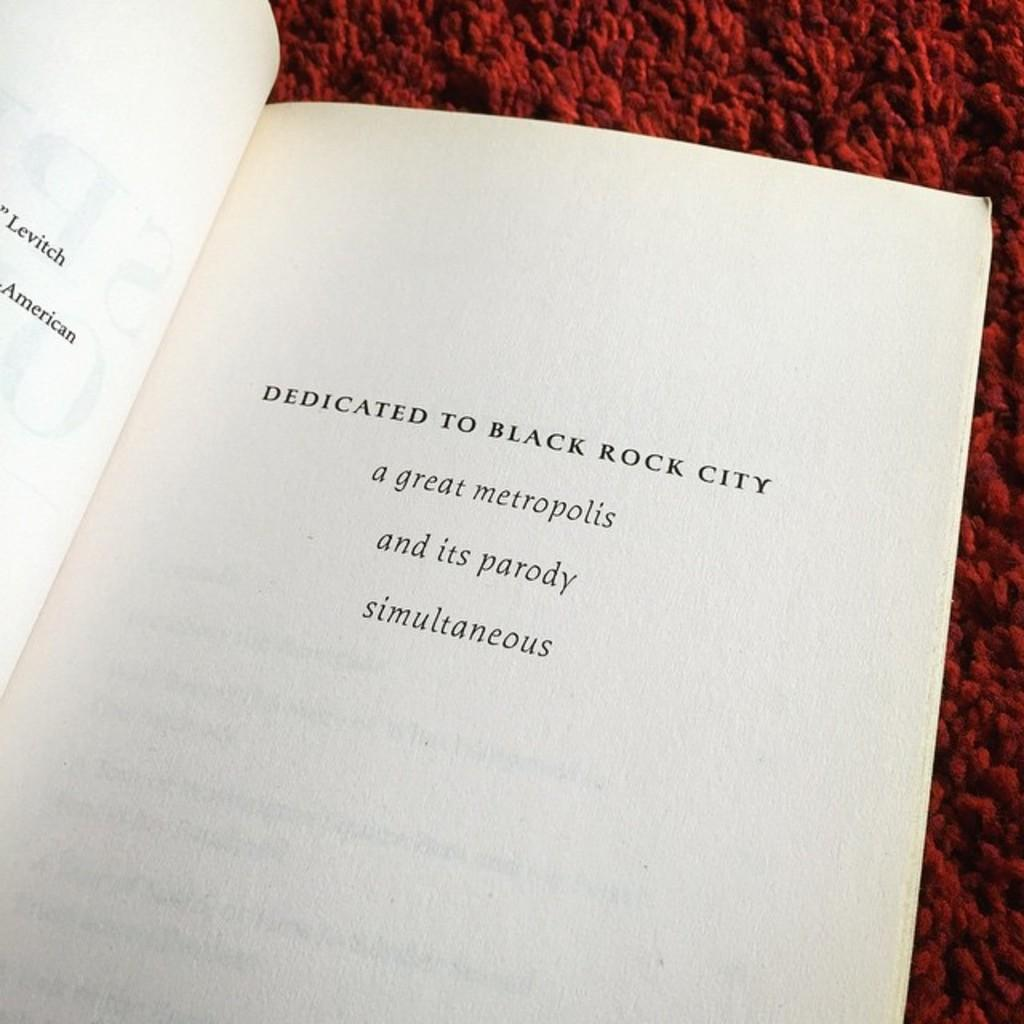<image>
Share a concise interpretation of the image provided. The book here is dedicated to Black Rock City 